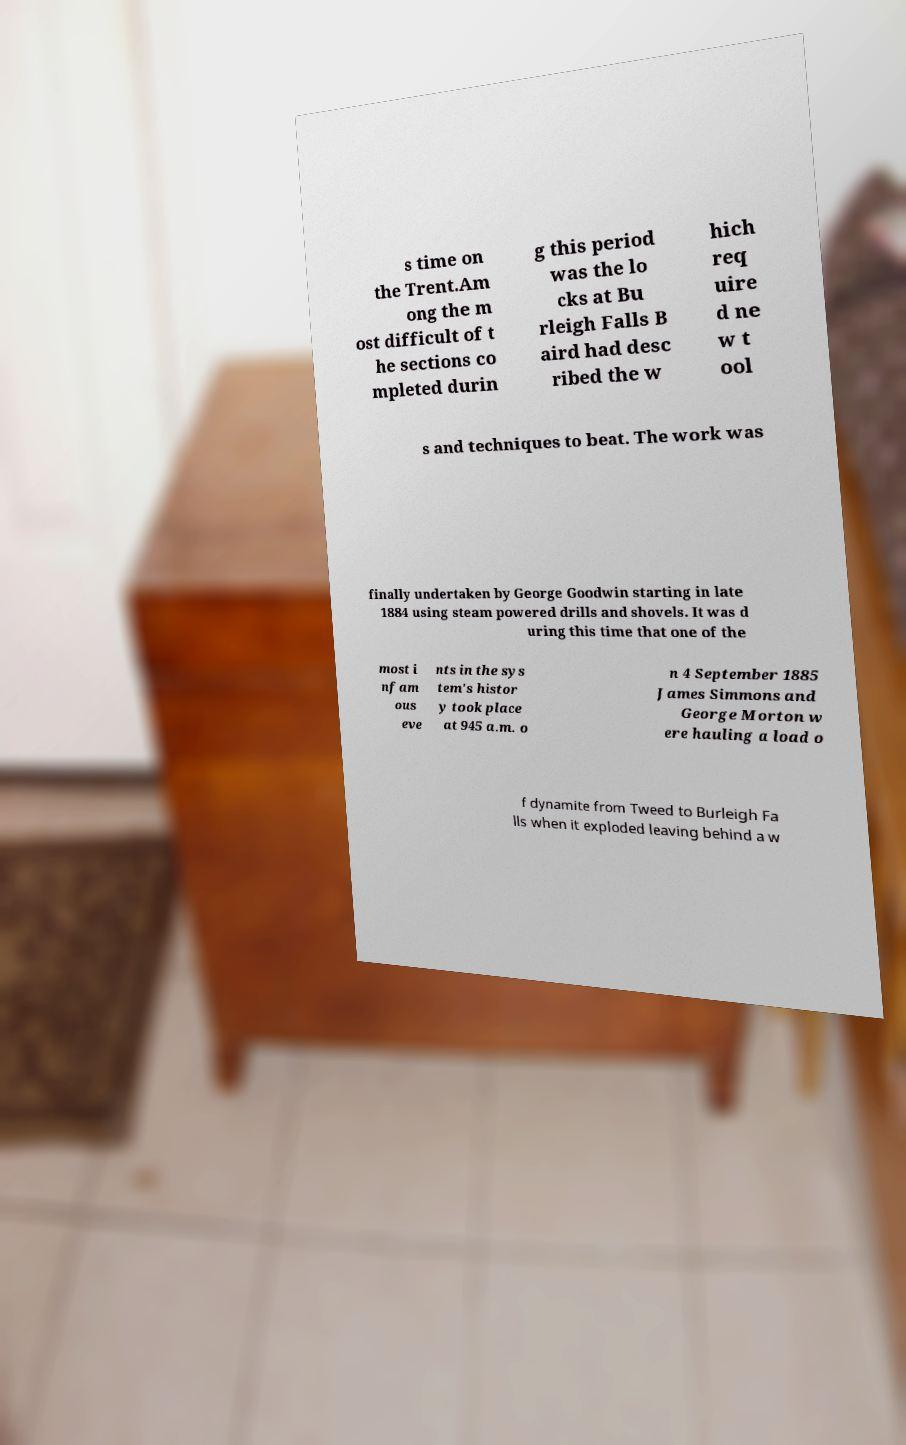Could you extract and type out the text from this image? s time on the Trent.Am ong the m ost difficult of t he sections co mpleted durin g this period was the lo cks at Bu rleigh Falls B aird had desc ribed the w hich req uire d ne w t ool s and techniques to beat. The work was finally undertaken by George Goodwin starting in late 1884 using steam powered drills and shovels. It was d uring this time that one of the most i nfam ous eve nts in the sys tem's histor y took place at 945 a.m. o n 4 September 1885 James Simmons and George Morton w ere hauling a load o f dynamite from Tweed to Burleigh Fa lls when it exploded leaving behind a w 